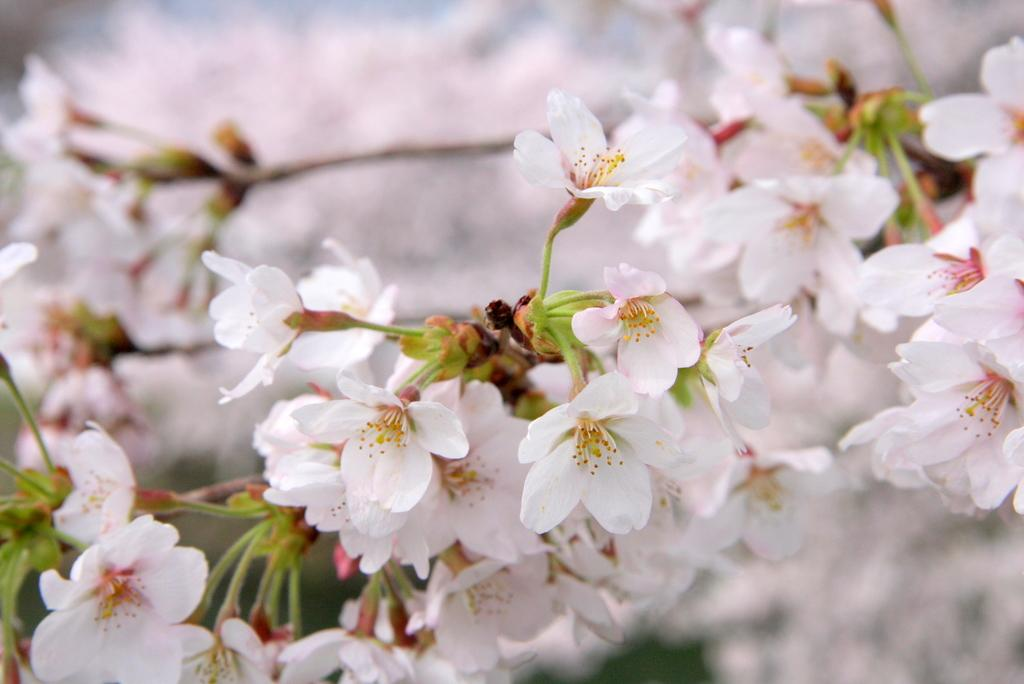What is present in the foreground of the image? There are flowers in the foreground of the image. What is visible in the background of the image? There are flowers in the background of the image. What shapes can be seen on the petals of the flowers in the image? The provided facts do not mention any specific shapes on the petals of the flowers, so we cannot determine the shapes from the image. 